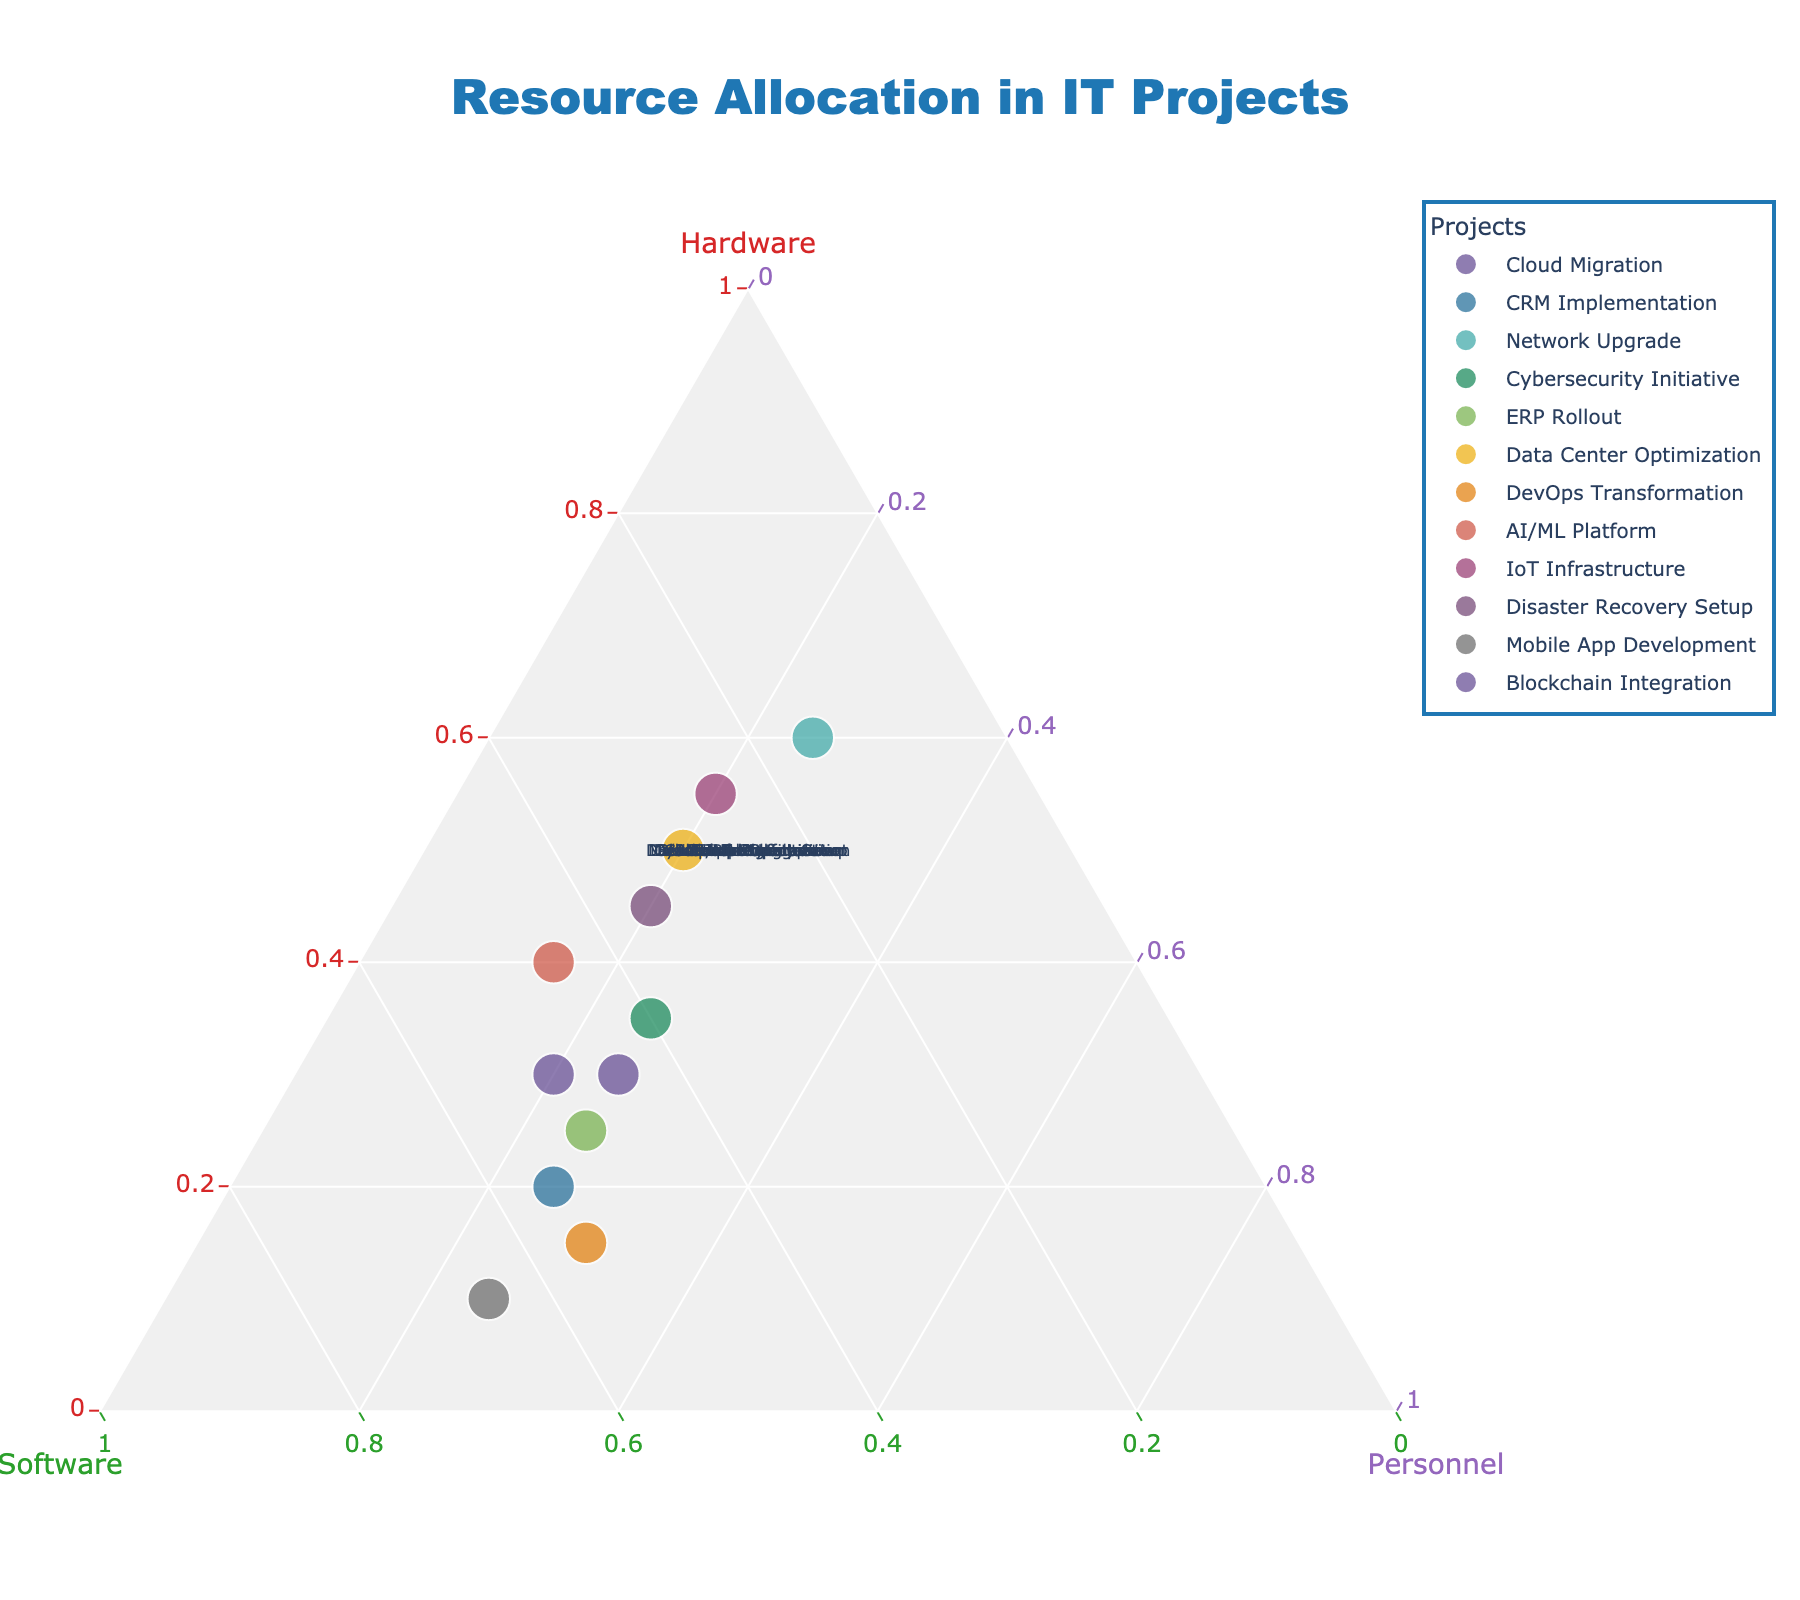What's the title of the plot? The title of the plot is typically found at the top and it summarises the content or the main idea of the figure. In this case, it clearly states the focus of the plot.
Answer: Resource Allocation in IT Projects How many projects are represented in the plot? To determine the number of projects, count the number of labeled data points or annotations on the plot. Each project corresponds to one data point.
Answer: 12 Which project allocates the highest percentage to software? Identify the data point that lies closest to the Software vertex (b-axis). The project with the highest software allocation will be the closest to this vertex.
Answer: Mobile App Development What percentage of resources does the DevOps Transformation project allocate to hardware and personnel combined? Locate the DevOps Transformation data point and read the values for hardware and personnel. Sum these values to get the combined allocation.
Answer: 15 (Hardware) + 30 (Personnel) = 45% Which two projects have the same allocation for personnel? Look for projects where the Personnel value (c-axis) is the same. From the data and plot, check which projects share this value.
Answer: Cloud Migration and CRM Implementation both allocate 25% to personnel How does the hardware allocation for the Network Upgrade compare to the software allocation for the same project? Identify the Network Upgrade data point and compare its hardware and software values. Note which value is greater.
Answer: The hardware allocation (60) is greater than the software allocation (15) What is the average software allocation percentage across all projects? Sum the software allocation values for all projects and divide by the number of projects to get the average. Explanation: (45+55+15+40+50+30+55+45+25+35+65+50) / 12 = 510 / 12
Answer: 42.5% Which project lies closest to the Personnel vertex, and what is its personnel allocation? Identify the data point closest to the Personnel vertex (c-axis), which will have the highest personnel allocation.
Answer: DevOps Transformation; 30% What is the difference in hardware allocation between the IoT Infrastructure and the AI/ML Platform projects? Find the hardware allocation values for both IoT Infrastructure and AI/ML Platform. Calculate the difference between these values. Explanation: IoT Infrastructure (55) - AI/ML Platform (40)
Answer: 15% Which project has the most balanced allocation across all three categories? Look for the data point that is closest to the center of the plot, indicating a more balanced allocation among hardware, software, and personnel. Assess the proximity to all vertices.
Answer: Cybersecurity Initiative 